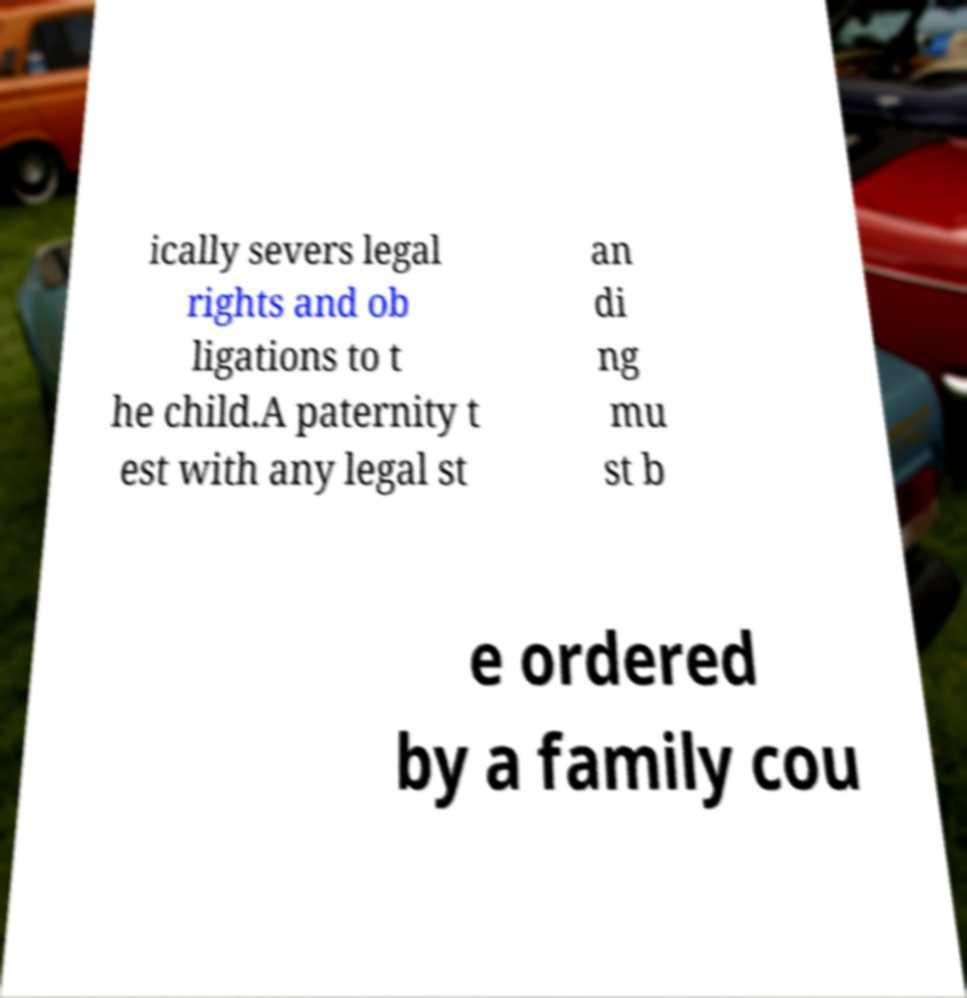Can you read and provide the text displayed in the image?This photo seems to have some interesting text. Can you extract and type it out for me? ically severs legal rights and ob ligations to t he child.A paternity t est with any legal st an di ng mu st b e ordered by a family cou 